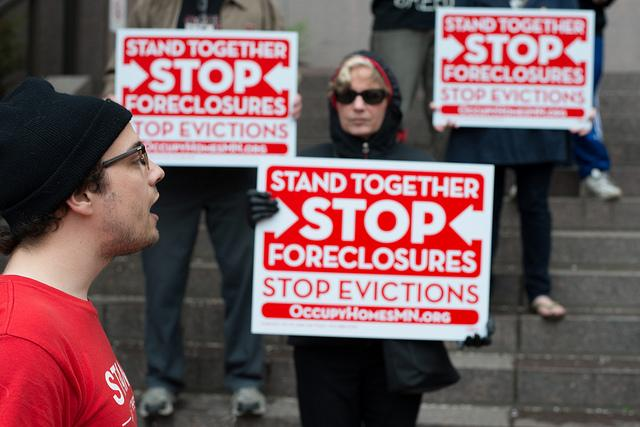What might the item on the woman's face be used to shield from? Please explain your reasoning. sun. The glasses are keeping the light off her eyes. 